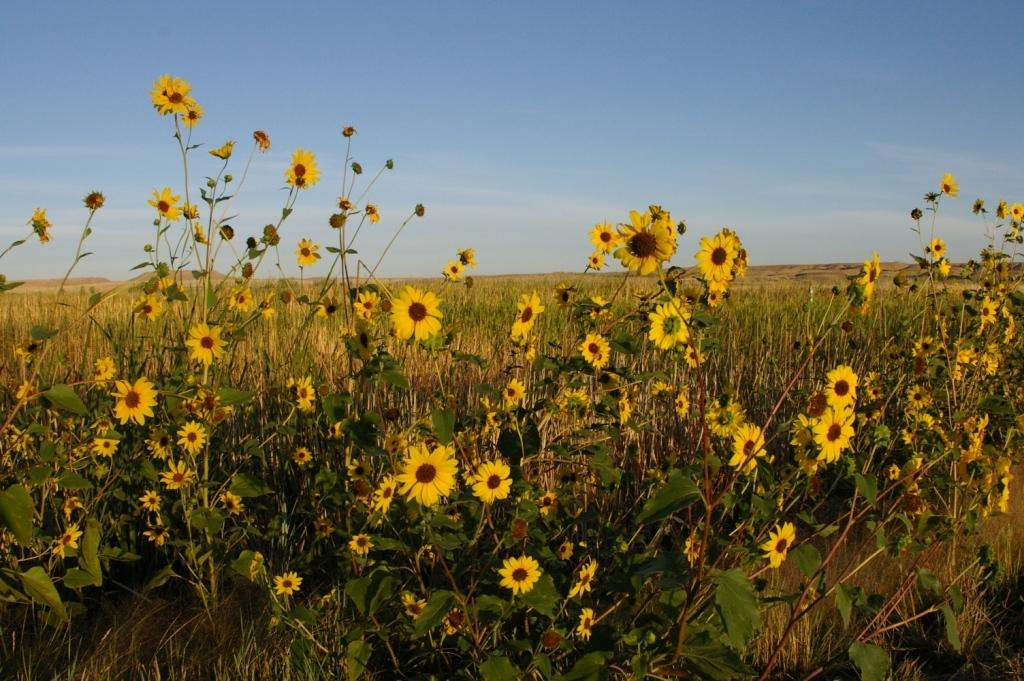What type of plants are in the image? There are sunflower plants in the image. What color are the sunflower plants? The sunflower plants are yellow in color. What else can be seen in the image besides the sunflower plants? The sky is visible in the image. What type of beef can be seen in the image? There is no beef present in the image; it features sunflower plants and the sky. Can you tell me how many people are smiling in the image? There are no people present in the image, so it is not possible to determine how many are smiling. 